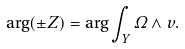<formula> <loc_0><loc_0><loc_500><loc_500>\arg ( \pm Z ) = \arg \int _ { Y } \Omega \wedge v .</formula> 